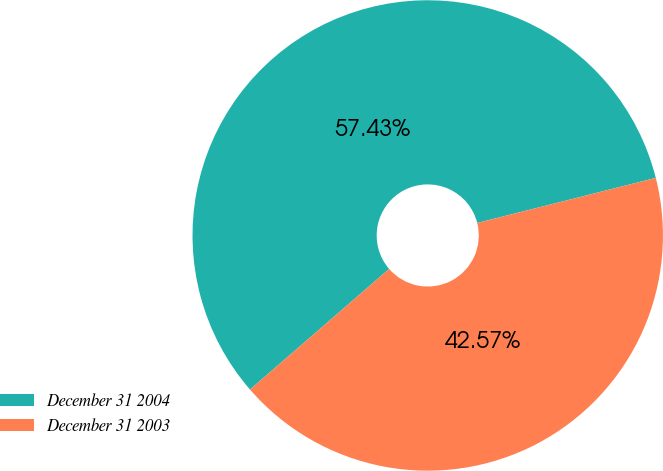<chart> <loc_0><loc_0><loc_500><loc_500><pie_chart><fcel>December 31 2004<fcel>December 31 2003<nl><fcel>57.43%<fcel>42.57%<nl></chart> 